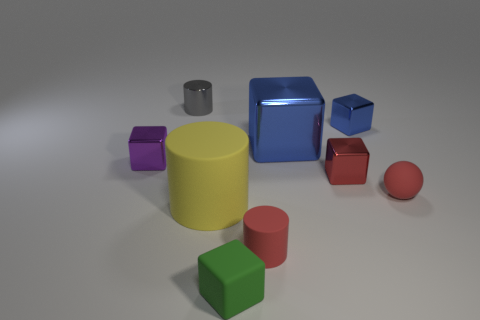How many cubes are small matte things or tiny red objects?
Give a very brief answer. 2. There is a tiny thing that is behind the purple metallic thing and in front of the small gray shiny cylinder; what material is it made of?
Make the answer very short. Metal. How many cubes are behind the small red matte sphere?
Offer a very short reply. 4. Do the cylinder behind the small purple cube and the tiny cylinder in front of the tiny metal cylinder have the same material?
Your answer should be compact. No. What number of objects are tiny cylinders in front of the small purple shiny thing or small red matte blocks?
Ensure brevity in your answer.  1. Is the number of red matte things to the left of the yellow cylinder less than the number of blue shiny objects in front of the large blue thing?
Give a very brief answer. No. What number of other things are the same size as the rubber cube?
Your answer should be very brief. 6. Are the small sphere and the big thing left of the big blue thing made of the same material?
Offer a very short reply. Yes. How many objects are red objects that are to the left of the tiny sphere or rubber cylinders on the left side of the tiny green matte cube?
Offer a terse response. 3. The tiny rubber cylinder is what color?
Your answer should be compact. Red. 